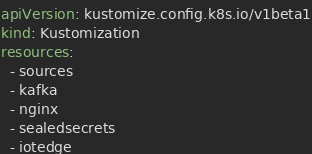Convert code to text. <code><loc_0><loc_0><loc_500><loc_500><_YAML_>apiVersion: kustomize.config.k8s.io/v1beta1
kind: Kustomization
resources:
  - sources
  - kafka
  - nginx
  - sealedsecrets
  - iotedge
</code> 